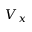<formula> <loc_0><loc_0><loc_500><loc_500>V _ { x }</formula> 